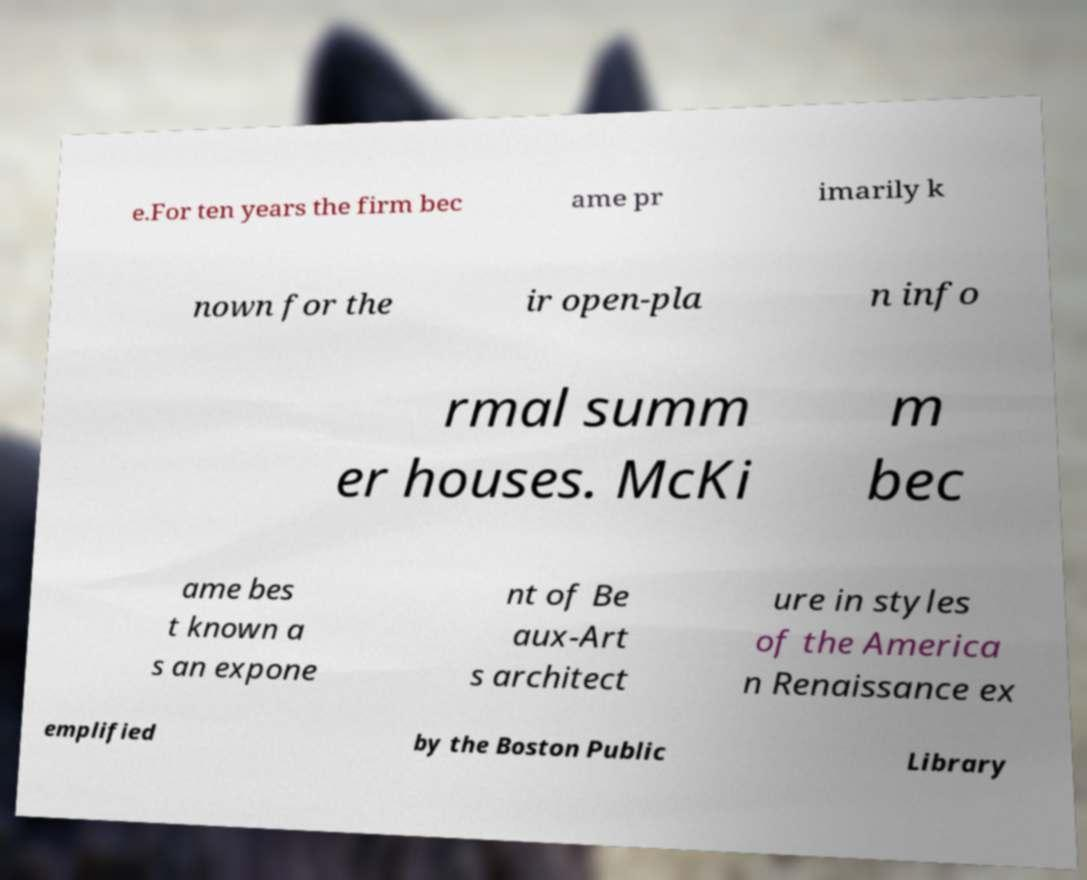There's text embedded in this image that I need extracted. Can you transcribe it verbatim? e.For ten years the firm bec ame pr imarily k nown for the ir open-pla n info rmal summ er houses. McKi m bec ame bes t known a s an expone nt of Be aux-Art s architect ure in styles of the America n Renaissance ex emplified by the Boston Public Library 